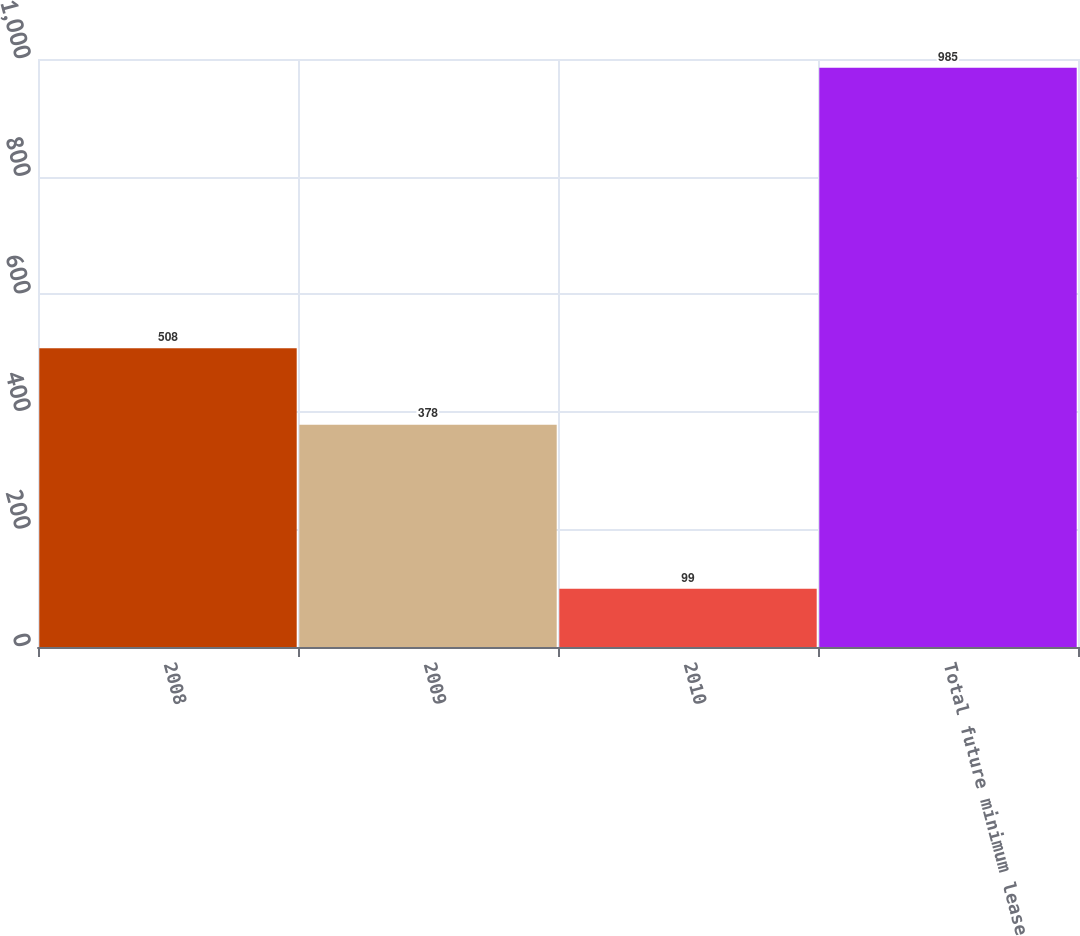Convert chart. <chart><loc_0><loc_0><loc_500><loc_500><bar_chart><fcel>2008<fcel>2009<fcel>2010<fcel>Total future minimum lease<nl><fcel>508<fcel>378<fcel>99<fcel>985<nl></chart> 